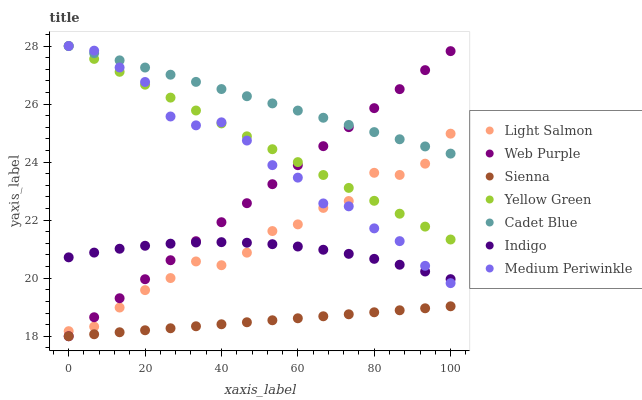Does Sienna have the minimum area under the curve?
Answer yes or no. Yes. Does Cadet Blue have the maximum area under the curve?
Answer yes or no. Yes. Does Indigo have the minimum area under the curve?
Answer yes or no. No. Does Indigo have the maximum area under the curve?
Answer yes or no. No. Is Sienna the smoothest?
Answer yes or no. Yes. Is Medium Periwinkle the roughest?
Answer yes or no. Yes. Is Cadet Blue the smoothest?
Answer yes or no. No. Is Cadet Blue the roughest?
Answer yes or no. No. Does Sienna have the lowest value?
Answer yes or no. Yes. Does Indigo have the lowest value?
Answer yes or no. No. Does Medium Periwinkle have the highest value?
Answer yes or no. Yes. Does Indigo have the highest value?
Answer yes or no. No. Is Sienna less than Indigo?
Answer yes or no. Yes. Is Yellow Green greater than Indigo?
Answer yes or no. Yes. Does Web Purple intersect Light Salmon?
Answer yes or no. Yes. Is Web Purple less than Light Salmon?
Answer yes or no. No. Is Web Purple greater than Light Salmon?
Answer yes or no. No. Does Sienna intersect Indigo?
Answer yes or no. No. 